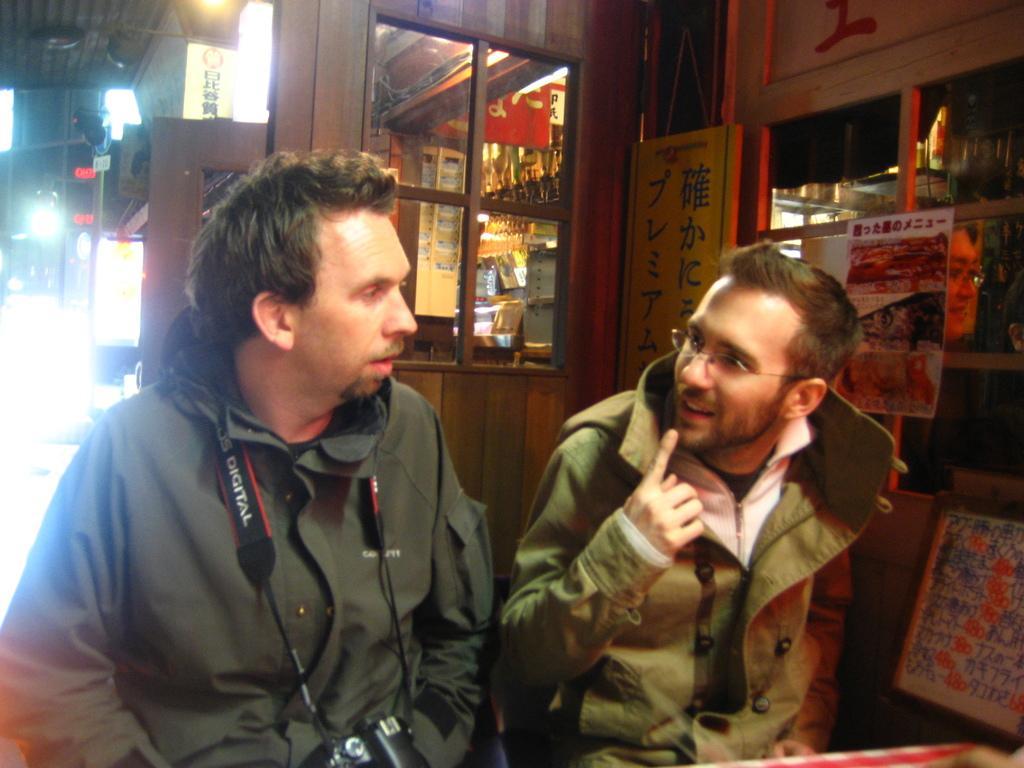Can you describe this image briefly? In this image we can see men sitting on the seating stools and one of them is wearing a camera around his neck. In the background we can see electric lights, stores, information boards, name boards and poles. 